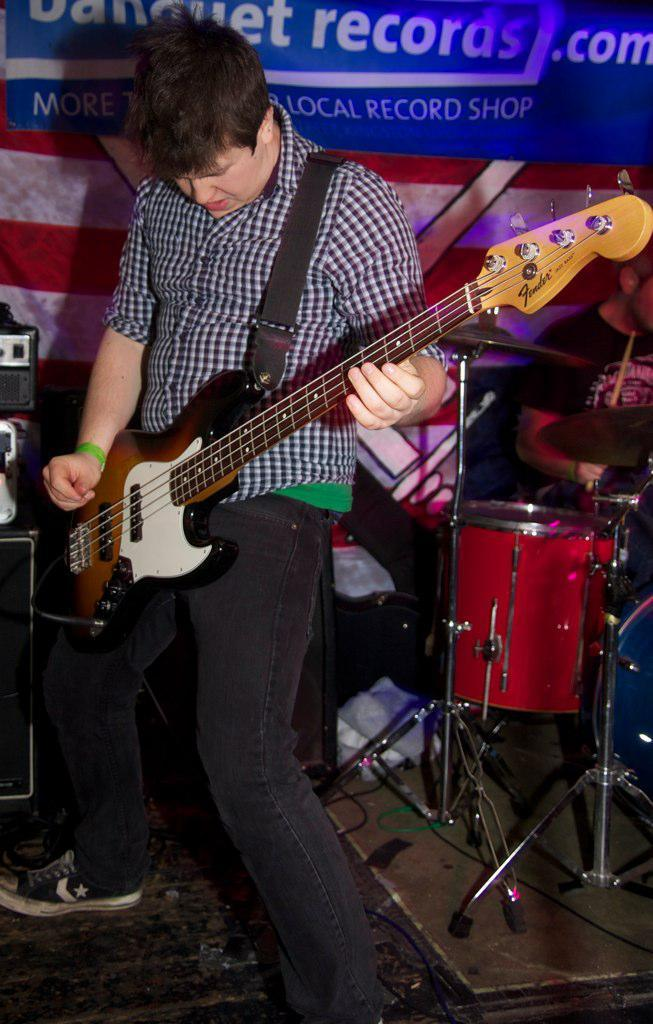What is the main subject of the image? The main subject of the image is a man. What is the man wearing in the image? The man is wearing a check shirt, trousers, and shoes. What activity is the man engaged in? The man is playing a guitar. What other musical instruments can be seen in the background of the image? There are drums in the background of the image. What additional objects are present in the background of the image? There is a speaker and a poster in the background of the image. What type of whip is the man using to play the guitar in the image? There is no whip present in the image; the man is playing the guitar using his hands. How many sheep are in the flock visible in the image? There is no flock of sheep present in the image; the image features a man playing a guitar and various objects in the background. 